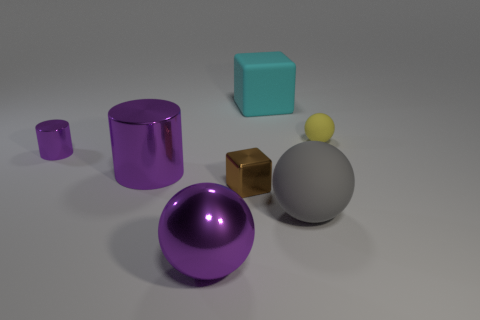Add 2 green matte cylinders. How many objects exist? 9 Subtract all brown blocks. How many blocks are left? 1 Subtract all rubber balls. How many balls are left? 1 Subtract 1 balls. How many balls are left? 2 Subtract all green cylinders. Subtract all gray balls. How many cylinders are left? 2 Subtract all blue spheres. How many green cubes are left? 0 Subtract all gray objects. Subtract all tiny green balls. How many objects are left? 6 Add 5 purple spheres. How many purple spheres are left? 6 Add 1 small gray cubes. How many small gray cubes exist? 1 Subtract 0 blue cylinders. How many objects are left? 7 